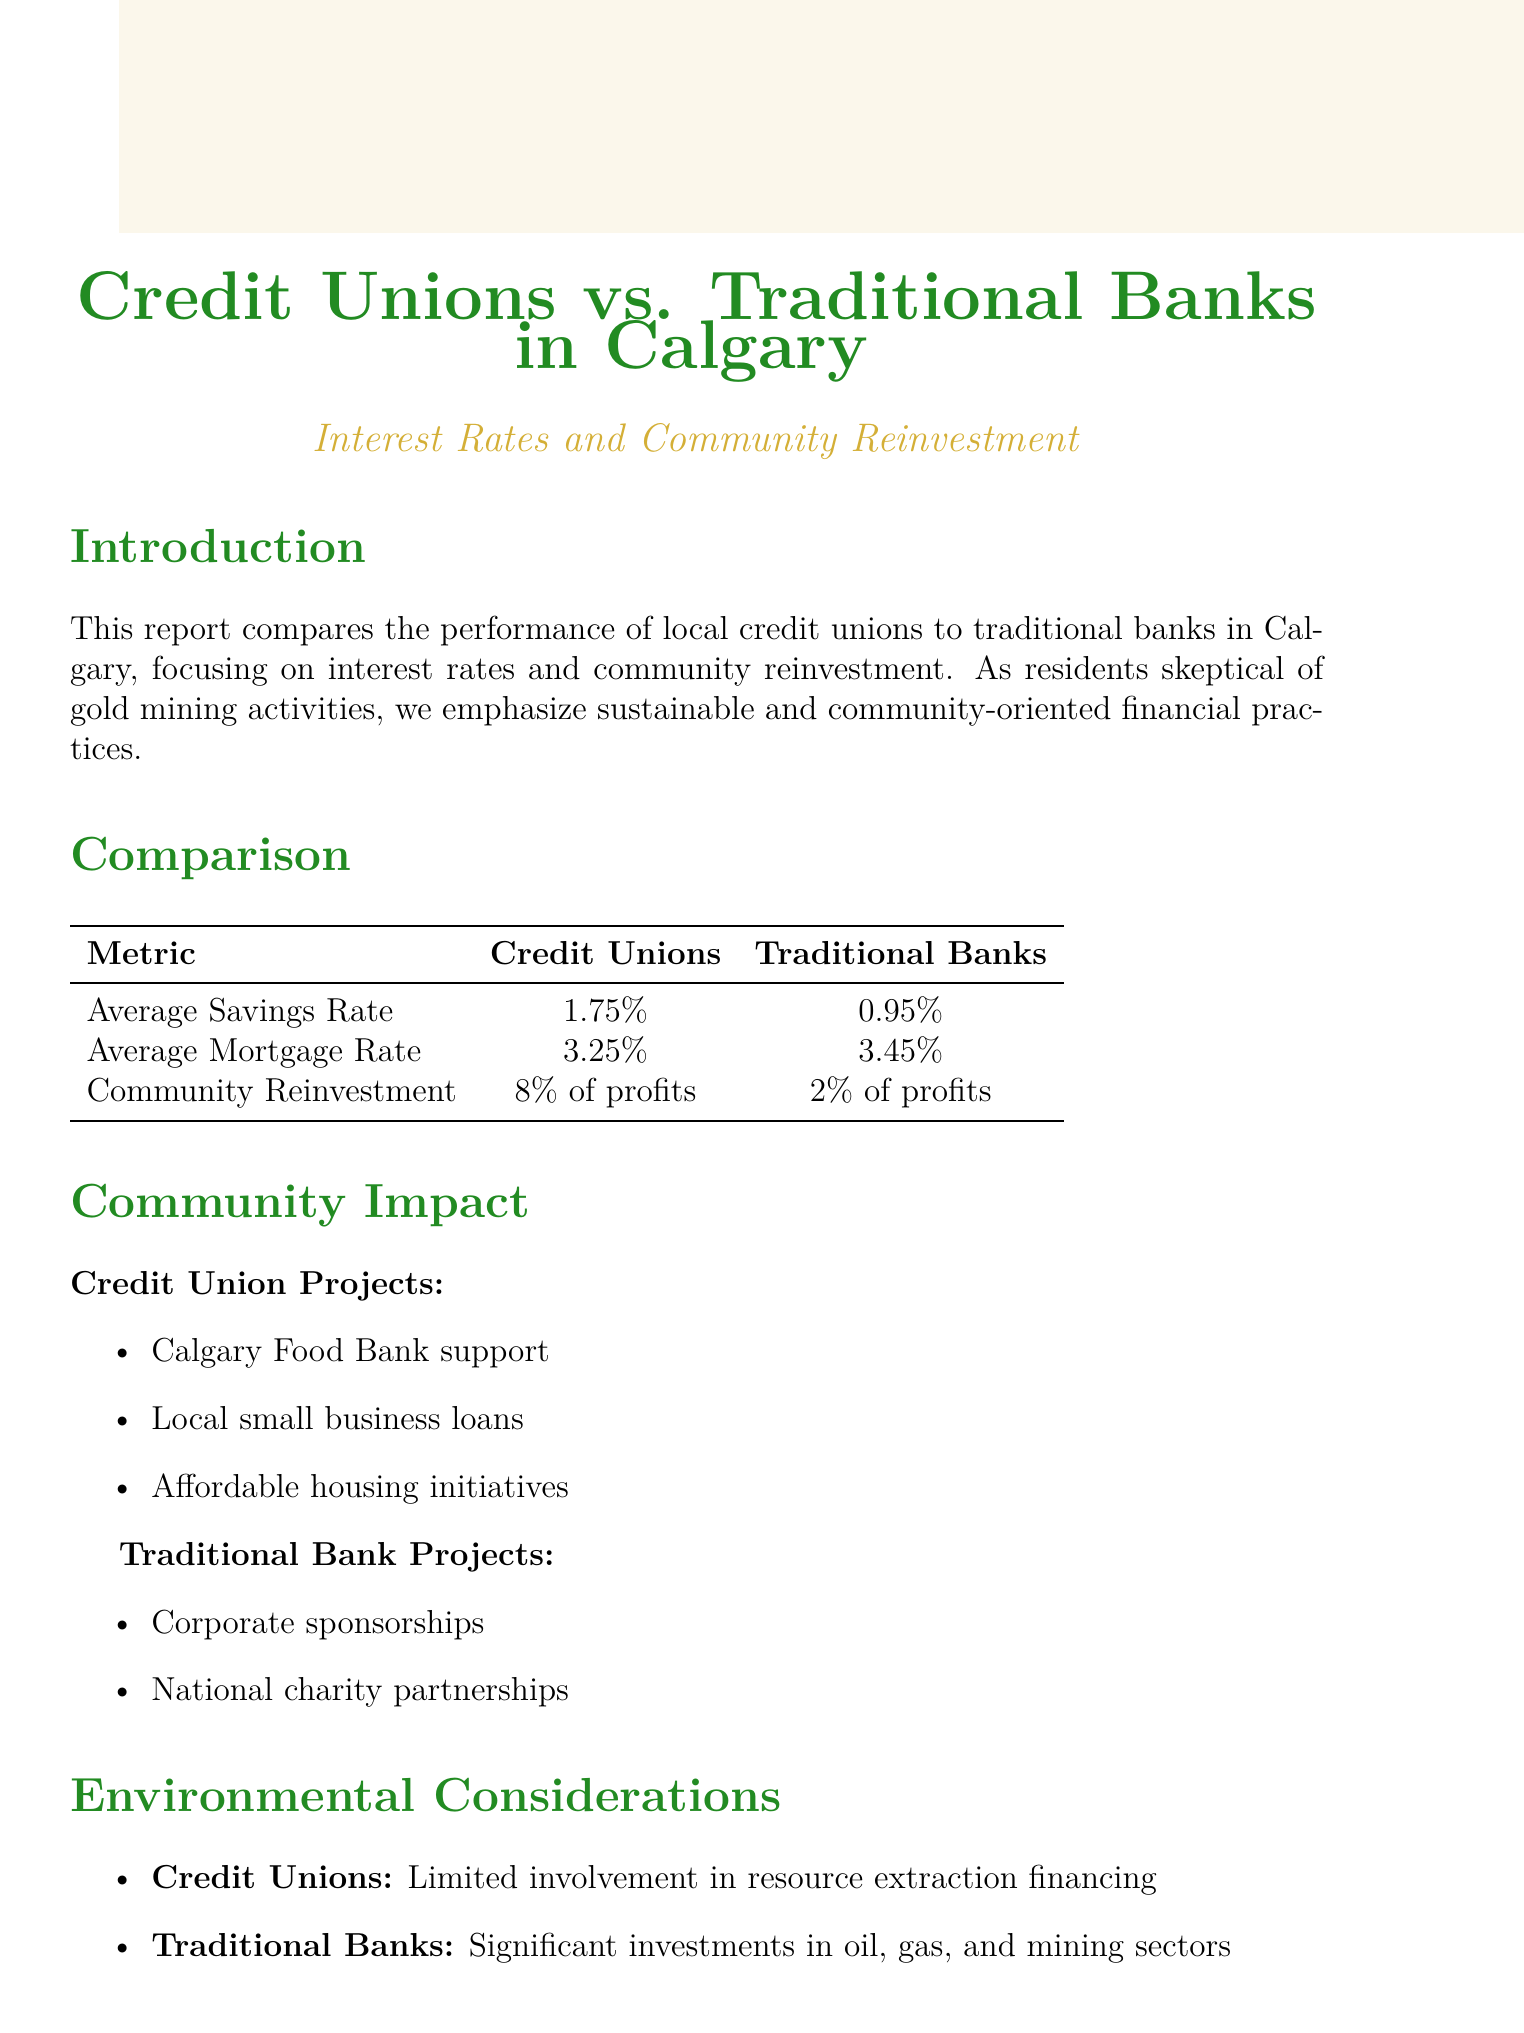What is the average savings rate for credit unions? The average savings rate for credit unions is stated in the document, which is 1.75%.
Answer: 1.75% What is the average mortgage rate for traditional banks? The average mortgage rate for traditional banks is provided as 3.45%.
Answer: 3.45% What percentage of profits do credit unions allocate to community reinvestment? The document specifies that credit unions allocate 8% of profits to community initiatives.
Answer: 8% List one project supported by credit unions. The report discusses various projects, including support for the Calgary Food Bank.
Answer: Calgary Food Bank support What type of projects do traditional banks pursue according to the document? The document mentions that traditional banks engage in corporate sponsorships as part of their projects.
Answer: Corporate sponsorships Which type of financial institution has limited involvement in resource extraction financing? The report indicates that credit unions have limited involvement in resource extraction financing.
Answer: Credit unions What is emphasized in the introduction regarding financial practices? The introduction highlights the importance of sustainable and community-oriented financial practices.
Answer: Sustainable and community-oriented What is the community reinvestment percentage for traditional banks? The document shows that traditional banks invest 2% of profits into community reinvestment.
Answer: 2% What type of investments do traditional banks have significant involvement in? The report states that traditional banks have significant investments in oil, gas, and mining sectors.
Answer: Oil, gas, and mining sectors 